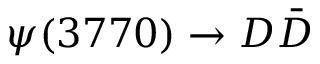Convert formula to latex. <formula><loc_0><loc_0><loc_500><loc_500>\psi ( 3 7 7 0 ) \to D \bar { D }</formula> 